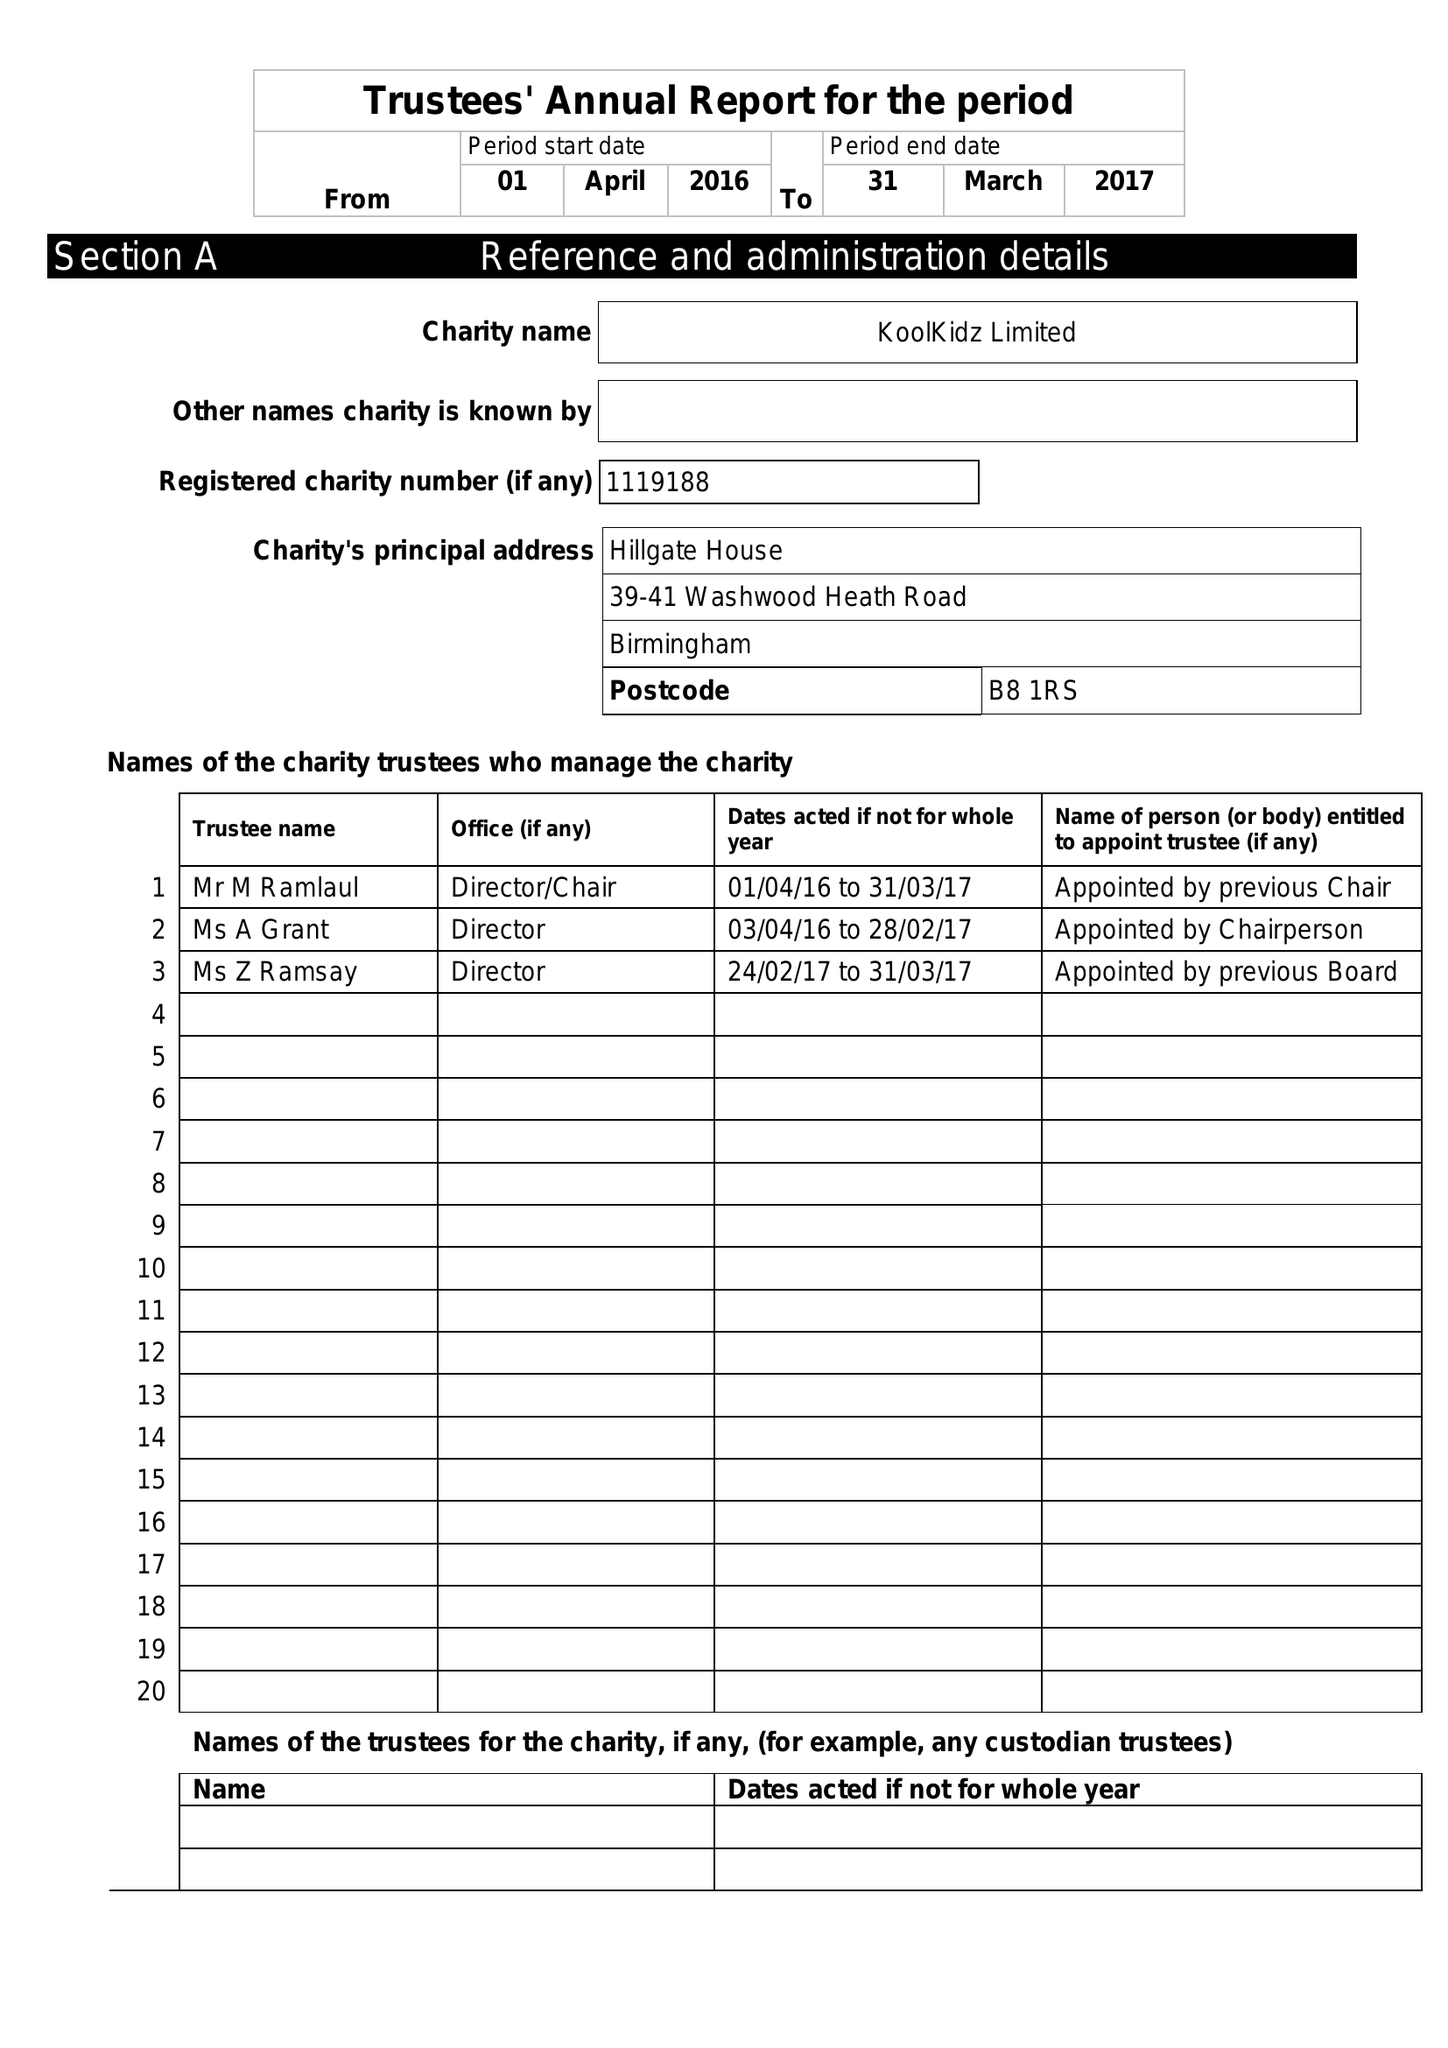What is the value for the address__post_town?
Answer the question using a single word or phrase. BIRMINGHAM 